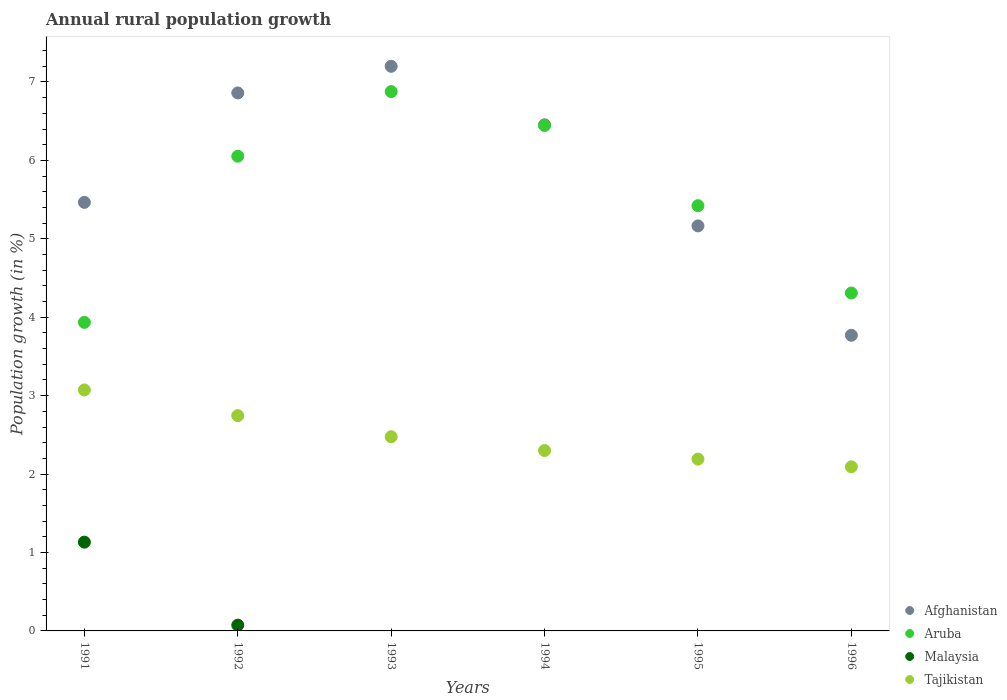How many different coloured dotlines are there?
Provide a succinct answer. 4. Is the number of dotlines equal to the number of legend labels?
Make the answer very short. No. What is the percentage of rural population growth in Malaysia in 1992?
Make the answer very short. 0.07. Across all years, what is the maximum percentage of rural population growth in Malaysia?
Make the answer very short. 1.13. Across all years, what is the minimum percentage of rural population growth in Afghanistan?
Make the answer very short. 3.77. What is the total percentage of rural population growth in Tajikistan in the graph?
Keep it short and to the point. 14.88. What is the difference between the percentage of rural population growth in Aruba in 1992 and that in 1996?
Make the answer very short. 1.74. What is the difference between the percentage of rural population growth in Aruba in 1991 and the percentage of rural population growth in Afghanistan in 1995?
Give a very brief answer. -1.23. What is the average percentage of rural population growth in Tajikistan per year?
Your answer should be compact. 2.48. In the year 1991, what is the difference between the percentage of rural population growth in Aruba and percentage of rural population growth in Tajikistan?
Your answer should be very brief. 0.86. In how many years, is the percentage of rural population growth in Aruba greater than 6 %?
Provide a short and direct response. 3. What is the ratio of the percentage of rural population growth in Tajikistan in 1991 to that in 1993?
Offer a terse response. 1.24. Is the difference between the percentage of rural population growth in Aruba in 1991 and 1994 greater than the difference between the percentage of rural population growth in Tajikistan in 1991 and 1994?
Make the answer very short. No. What is the difference between the highest and the second highest percentage of rural population growth in Aruba?
Keep it short and to the point. 0.43. What is the difference between the highest and the lowest percentage of rural population growth in Aruba?
Keep it short and to the point. 2.94. Is the sum of the percentage of rural population growth in Afghanistan in 1991 and 1992 greater than the maximum percentage of rural population growth in Aruba across all years?
Keep it short and to the point. Yes. Is it the case that in every year, the sum of the percentage of rural population growth in Malaysia and percentage of rural population growth in Aruba  is greater than the sum of percentage of rural population growth in Tajikistan and percentage of rural population growth in Afghanistan?
Offer a very short reply. No. Is it the case that in every year, the sum of the percentage of rural population growth in Afghanistan and percentage of rural population growth in Tajikistan  is greater than the percentage of rural population growth in Malaysia?
Offer a terse response. Yes. Does the percentage of rural population growth in Afghanistan monotonically increase over the years?
Your answer should be very brief. No. Is the percentage of rural population growth in Tajikistan strictly greater than the percentage of rural population growth in Aruba over the years?
Give a very brief answer. No. How many dotlines are there?
Your answer should be very brief. 4. How many years are there in the graph?
Give a very brief answer. 6. What is the difference between two consecutive major ticks on the Y-axis?
Your answer should be very brief. 1. Does the graph contain grids?
Give a very brief answer. No. Where does the legend appear in the graph?
Make the answer very short. Bottom right. How are the legend labels stacked?
Offer a very short reply. Vertical. What is the title of the graph?
Keep it short and to the point. Annual rural population growth. Does "Argentina" appear as one of the legend labels in the graph?
Give a very brief answer. No. What is the label or title of the Y-axis?
Offer a very short reply. Population growth (in %). What is the Population growth (in %) in Afghanistan in 1991?
Your answer should be compact. 5.46. What is the Population growth (in %) of Aruba in 1991?
Provide a short and direct response. 3.93. What is the Population growth (in %) of Malaysia in 1991?
Offer a very short reply. 1.13. What is the Population growth (in %) of Tajikistan in 1991?
Your response must be concise. 3.07. What is the Population growth (in %) of Afghanistan in 1992?
Your answer should be very brief. 6.86. What is the Population growth (in %) of Aruba in 1992?
Your answer should be very brief. 6.05. What is the Population growth (in %) in Malaysia in 1992?
Offer a very short reply. 0.07. What is the Population growth (in %) in Tajikistan in 1992?
Provide a succinct answer. 2.75. What is the Population growth (in %) of Afghanistan in 1993?
Keep it short and to the point. 7.2. What is the Population growth (in %) of Aruba in 1993?
Offer a very short reply. 6.88. What is the Population growth (in %) of Tajikistan in 1993?
Give a very brief answer. 2.48. What is the Population growth (in %) in Afghanistan in 1994?
Ensure brevity in your answer.  6.45. What is the Population growth (in %) of Aruba in 1994?
Offer a terse response. 6.44. What is the Population growth (in %) in Malaysia in 1994?
Keep it short and to the point. 0. What is the Population growth (in %) of Tajikistan in 1994?
Give a very brief answer. 2.3. What is the Population growth (in %) of Afghanistan in 1995?
Give a very brief answer. 5.16. What is the Population growth (in %) of Aruba in 1995?
Provide a short and direct response. 5.42. What is the Population growth (in %) in Tajikistan in 1995?
Your answer should be compact. 2.19. What is the Population growth (in %) of Afghanistan in 1996?
Give a very brief answer. 3.77. What is the Population growth (in %) in Aruba in 1996?
Provide a succinct answer. 4.31. What is the Population growth (in %) of Malaysia in 1996?
Give a very brief answer. 0. What is the Population growth (in %) of Tajikistan in 1996?
Ensure brevity in your answer.  2.09. Across all years, what is the maximum Population growth (in %) in Afghanistan?
Your response must be concise. 7.2. Across all years, what is the maximum Population growth (in %) in Aruba?
Offer a very short reply. 6.88. Across all years, what is the maximum Population growth (in %) in Malaysia?
Offer a terse response. 1.13. Across all years, what is the maximum Population growth (in %) in Tajikistan?
Offer a terse response. 3.07. Across all years, what is the minimum Population growth (in %) in Afghanistan?
Make the answer very short. 3.77. Across all years, what is the minimum Population growth (in %) of Aruba?
Ensure brevity in your answer.  3.93. Across all years, what is the minimum Population growth (in %) of Malaysia?
Your answer should be compact. 0. Across all years, what is the minimum Population growth (in %) in Tajikistan?
Offer a very short reply. 2.09. What is the total Population growth (in %) of Afghanistan in the graph?
Your answer should be very brief. 34.91. What is the total Population growth (in %) of Aruba in the graph?
Provide a succinct answer. 33.04. What is the total Population growth (in %) in Malaysia in the graph?
Keep it short and to the point. 1.21. What is the total Population growth (in %) in Tajikistan in the graph?
Make the answer very short. 14.88. What is the difference between the Population growth (in %) in Afghanistan in 1991 and that in 1992?
Offer a terse response. -1.4. What is the difference between the Population growth (in %) of Aruba in 1991 and that in 1992?
Ensure brevity in your answer.  -2.12. What is the difference between the Population growth (in %) in Malaysia in 1991 and that in 1992?
Make the answer very short. 1.06. What is the difference between the Population growth (in %) in Tajikistan in 1991 and that in 1992?
Provide a short and direct response. 0.33. What is the difference between the Population growth (in %) of Afghanistan in 1991 and that in 1993?
Give a very brief answer. -1.73. What is the difference between the Population growth (in %) of Aruba in 1991 and that in 1993?
Your response must be concise. -2.94. What is the difference between the Population growth (in %) of Tajikistan in 1991 and that in 1993?
Make the answer very short. 0.6. What is the difference between the Population growth (in %) in Afghanistan in 1991 and that in 1994?
Make the answer very short. -0.99. What is the difference between the Population growth (in %) in Aruba in 1991 and that in 1994?
Keep it short and to the point. -2.51. What is the difference between the Population growth (in %) in Tajikistan in 1991 and that in 1994?
Offer a very short reply. 0.77. What is the difference between the Population growth (in %) in Afghanistan in 1991 and that in 1995?
Your answer should be compact. 0.3. What is the difference between the Population growth (in %) of Aruba in 1991 and that in 1995?
Provide a succinct answer. -1.49. What is the difference between the Population growth (in %) in Tajikistan in 1991 and that in 1995?
Your answer should be very brief. 0.88. What is the difference between the Population growth (in %) of Afghanistan in 1991 and that in 1996?
Offer a very short reply. 1.69. What is the difference between the Population growth (in %) of Aruba in 1991 and that in 1996?
Give a very brief answer. -0.37. What is the difference between the Population growth (in %) in Tajikistan in 1991 and that in 1996?
Provide a short and direct response. 0.98. What is the difference between the Population growth (in %) of Afghanistan in 1992 and that in 1993?
Ensure brevity in your answer.  -0.34. What is the difference between the Population growth (in %) of Aruba in 1992 and that in 1993?
Ensure brevity in your answer.  -0.82. What is the difference between the Population growth (in %) of Tajikistan in 1992 and that in 1993?
Ensure brevity in your answer.  0.27. What is the difference between the Population growth (in %) of Afghanistan in 1992 and that in 1994?
Provide a short and direct response. 0.41. What is the difference between the Population growth (in %) of Aruba in 1992 and that in 1994?
Your answer should be compact. -0.39. What is the difference between the Population growth (in %) in Tajikistan in 1992 and that in 1994?
Your answer should be very brief. 0.45. What is the difference between the Population growth (in %) of Afghanistan in 1992 and that in 1995?
Make the answer very short. 1.7. What is the difference between the Population growth (in %) in Aruba in 1992 and that in 1995?
Keep it short and to the point. 0.63. What is the difference between the Population growth (in %) in Tajikistan in 1992 and that in 1995?
Your answer should be compact. 0.55. What is the difference between the Population growth (in %) in Afghanistan in 1992 and that in 1996?
Your answer should be compact. 3.09. What is the difference between the Population growth (in %) in Aruba in 1992 and that in 1996?
Make the answer very short. 1.74. What is the difference between the Population growth (in %) in Tajikistan in 1992 and that in 1996?
Offer a terse response. 0.65. What is the difference between the Population growth (in %) of Afghanistan in 1993 and that in 1994?
Your response must be concise. 0.75. What is the difference between the Population growth (in %) in Aruba in 1993 and that in 1994?
Give a very brief answer. 0.43. What is the difference between the Population growth (in %) in Tajikistan in 1993 and that in 1994?
Offer a terse response. 0.18. What is the difference between the Population growth (in %) of Afghanistan in 1993 and that in 1995?
Your response must be concise. 2.04. What is the difference between the Population growth (in %) in Aruba in 1993 and that in 1995?
Offer a terse response. 1.46. What is the difference between the Population growth (in %) in Tajikistan in 1993 and that in 1995?
Ensure brevity in your answer.  0.29. What is the difference between the Population growth (in %) of Afghanistan in 1993 and that in 1996?
Your answer should be compact. 3.43. What is the difference between the Population growth (in %) in Aruba in 1993 and that in 1996?
Your answer should be very brief. 2.57. What is the difference between the Population growth (in %) of Tajikistan in 1993 and that in 1996?
Offer a terse response. 0.38. What is the difference between the Population growth (in %) in Afghanistan in 1994 and that in 1995?
Keep it short and to the point. 1.29. What is the difference between the Population growth (in %) of Aruba in 1994 and that in 1995?
Make the answer very short. 1.02. What is the difference between the Population growth (in %) of Tajikistan in 1994 and that in 1995?
Provide a short and direct response. 0.11. What is the difference between the Population growth (in %) of Afghanistan in 1994 and that in 1996?
Ensure brevity in your answer.  2.68. What is the difference between the Population growth (in %) in Aruba in 1994 and that in 1996?
Make the answer very short. 2.14. What is the difference between the Population growth (in %) in Tajikistan in 1994 and that in 1996?
Offer a very short reply. 0.21. What is the difference between the Population growth (in %) in Afghanistan in 1995 and that in 1996?
Offer a very short reply. 1.39. What is the difference between the Population growth (in %) of Aruba in 1995 and that in 1996?
Your answer should be compact. 1.11. What is the difference between the Population growth (in %) of Tajikistan in 1995 and that in 1996?
Make the answer very short. 0.1. What is the difference between the Population growth (in %) in Afghanistan in 1991 and the Population growth (in %) in Aruba in 1992?
Offer a very short reply. -0.59. What is the difference between the Population growth (in %) in Afghanistan in 1991 and the Population growth (in %) in Malaysia in 1992?
Make the answer very short. 5.39. What is the difference between the Population growth (in %) in Afghanistan in 1991 and the Population growth (in %) in Tajikistan in 1992?
Provide a succinct answer. 2.72. What is the difference between the Population growth (in %) of Aruba in 1991 and the Population growth (in %) of Malaysia in 1992?
Offer a very short reply. 3.86. What is the difference between the Population growth (in %) in Aruba in 1991 and the Population growth (in %) in Tajikistan in 1992?
Your response must be concise. 1.19. What is the difference between the Population growth (in %) of Malaysia in 1991 and the Population growth (in %) of Tajikistan in 1992?
Your answer should be very brief. -1.61. What is the difference between the Population growth (in %) of Afghanistan in 1991 and the Population growth (in %) of Aruba in 1993?
Your answer should be compact. -1.41. What is the difference between the Population growth (in %) of Afghanistan in 1991 and the Population growth (in %) of Tajikistan in 1993?
Your response must be concise. 2.99. What is the difference between the Population growth (in %) of Aruba in 1991 and the Population growth (in %) of Tajikistan in 1993?
Offer a very short reply. 1.46. What is the difference between the Population growth (in %) of Malaysia in 1991 and the Population growth (in %) of Tajikistan in 1993?
Provide a succinct answer. -1.34. What is the difference between the Population growth (in %) of Afghanistan in 1991 and the Population growth (in %) of Aruba in 1994?
Your response must be concise. -0.98. What is the difference between the Population growth (in %) of Afghanistan in 1991 and the Population growth (in %) of Tajikistan in 1994?
Keep it short and to the point. 3.16. What is the difference between the Population growth (in %) of Aruba in 1991 and the Population growth (in %) of Tajikistan in 1994?
Make the answer very short. 1.63. What is the difference between the Population growth (in %) in Malaysia in 1991 and the Population growth (in %) in Tajikistan in 1994?
Offer a terse response. -1.17. What is the difference between the Population growth (in %) of Afghanistan in 1991 and the Population growth (in %) of Aruba in 1995?
Offer a terse response. 0.04. What is the difference between the Population growth (in %) in Afghanistan in 1991 and the Population growth (in %) in Tajikistan in 1995?
Keep it short and to the point. 3.27. What is the difference between the Population growth (in %) in Aruba in 1991 and the Population growth (in %) in Tajikistan in 1995?
Make the answer very short. 1.74. What is the difference between the Population growth (in %) of Malaysia in 1991 and the Population growth (in %) of Tajikistan in 1995?
Provide a succinct answer. -1.06. What is the difference between the Population growth (in %) of Afghanistan in 1991 and the Population growth (in %) of Aruba in 1996?
Ensure brevity in your answer.  1.16. What is the difference between the Population growth (in %) of Afghanistan in 1991 and the Population growth (in %) of Tajikistan in 1996?
Make the answer very short. 3.37. What is the difference between the Population growth (in %) in Aruba in 1991 and the Population growth (in %) in Tajikistan in 1996?
Offer a terse response. 1.84. What is the difference between the Population growth (in %) of Malaysia in 1991 and the Population growth (in %) of Tajikistan in 1996?
Make the answer very short. -0.96. What is the difference between the Population growth (in %) in Afghanistan in 1992 and the Population growth (in %) in Aruba in 1993?
Your answer should be compact. -0.02. What is the difference between the Population growth (in %) of Afghanistan in 1992 and the Population growth (in %) of Tajikistan in 1993?
Ensure brevity in your answer.  4.38. What is the difference between the Population growth (in %) in Aruba in 1992 and the Population growth (in %) in Tajikistan in 1993?
Your answer should be compact. 3.58. What is the difference between the Population growth (in %) in Malaysia in 1992 and the Population growth (in %) in Tajikistan in 1993?
Your answer should be very brief. -2.4. What is the difference between the Population growth (in %) in Afghanistan in 1992 and the Population growth (in %) in Aruba in 1994?
Give a very brief answer. 0.42. What is the difference between the Population growth (in %) of Afghanistan in 1992 and the Population growth (in %) of Tajikistan in 1994?
Your answer should be compact. 4.56. What is the difference between the Population growth (in %) in Aruba in 1992 and the Population growth (in %) in Tajikistan in 1994?
Your answer should be compact. 3.75. What is the difference between the Population growth (in %) of Malaysia in 1992 and the Population growth (in %) of Tajikistan in 1994?
Give a very brief answer. -2.23. What is the difference between the Population growth (in %) in Afghanistan in 1992 and the Population growth (in %) in Aruba in 1995?
Ensure brevity in your answer.  1.44. What is the difference between the Population growth (in %) in Afghanistan in 1992 and the Population growth (in %) in Tajikistan in 1995?
Keep it short and to the point. 4.67. What is the difference between the Population growth (in %) of Aruba in 1992 and the Population growth (in %) of Tajikistan in 1995?
Your answer should be very brief. 3.86. What is the difference between the Population growth (in %) in Malaysia in 1992 and the Population growth (in %) in Tajikistan in 1995?
Your answer should be very brief. -2.12. What is the difference between the Population growth (in %) of Afghanistan in 1992 and the Population growth (in %) of Aruba in 1996?
Your response must be concise. 2.55. What is the difference between the Population growth (in %) in Afghanistan in 1992 and the Population growth (in %) in Tajikistan in 1996?
Make the answer very short. 4.77. What is the difference between the Population growth (in %) in Aruba in 1992 and the Population growth (in %) in Tajikistan in 1996?
Your answer should be compact. 3.96. What is the difference between the Population growth (in %) of Malaysia in 1992 and the Population growth (in %) of Tajikistan in 1996?
Make the answer very short. -2.02. What is the difference between the Population growth (in %) of Afghanistan in 1993 and the Population growth (in %) of Aruba in 1994?
Provide a succinct answer. 0.75. What is the difference between the Population growth (in %) of Afghanistan in 1993 and the Population growth (in %) of Tajikistan in 1994?
Your response must be concise. 4.9. What is the difference between the Population growth (in %) of Aruba in 1993 and the Population growth (in %) of Tajikistan in 1994?
Make the answer very short. 4.58. What is the difference between the Population growth (in %) in Afghanistan in 1993 and the Population growth (in %) in Aruba in 1995?
Your response must be concise. 1.78. What is the difference between the Population growth (in %) of Afghanistan in 1993 and the Population growth (in %) of Tajikistan in 1995?
Your response must be concise. 5.01. What is the difference between the Population growth (in %) in Aruba in 1993 and the Population growth (in %) in Tajikistan in 1995?
Ensure brevity in your answer.  4.69. What is the difference between the Population growth (in %) of Afghanistan in 1993 and the Population growth (in %) of Aruba in 1996?
Offer a terse response. 2.89. What is the difference between the Population growth (in %) in Afghanistan in 1993 and the Population growth (in %) in Tajikistan in 1996?
Your answer should be very brief. 5.11. What is the difference between the Population growth (in %) of Aruba in 1993 and the Population growth (in %) of Tajikistan in 1996?
Give a very brief answer. 4.78. What is the difference between the Population growth (in %) of Afghanistan in 1994 and the Population growth (in %) of Aruba in 1995?
Give a very brief answer. 1.03. What is the difference between the Population growth (in %) in Afghanistan in 1994 and the Population growth (in %) in Tajikistan in 1995?
Your answer should be compact. 4.26. What is the difference between the Population growth (in %) in Aruba in 1994 and the Population growth (in %) in Tajikistan in 1995?
Provide a short and direct response. 4.25. What is the difference between the Population growth (in %) of Afghanistan in 1994 and the Population growth (in %) of Aruba in 1996?
Your answer should be compact. 2.14. What is the difference between the Population growth (in %) of Afghanistan in 1994 and the Population growth (in %) of Tajikistan in 1996?
Make the answer very short. 4.36. What is the difference between the Population growth (in %) in Aruba in 1994 and the Population growth (in %) in Tajikistan in 1996?
Your answer should be compact. 4.35. What is the difference between the Population growth (in %) of Afghanistan in 1995 and the Population growth (in %) of Aruba in 1996?
Your answer should be very brief. 0.86. What is the difference between the Population growth (in %) in Afghanistan in 1995 and the Population growth (in %) in Tajikistan in 1996?
Provide a short and direct response. 3.07. What is the difference between the Population growth (in %) in Aruba in 1995 and the Population growth (in %) in Tajikistan in 1996?
Provide a short and direct response. 3.33. What is the average Population growth (in %) of Afghanistan per year?
Give a very brief answer. 5.82. What is the average Population growth (in %) of Aruba per year?
Make the answer very short. 5.51. What is the average Population growth (in %) in Malaysia per year?
Provide a succinct answer. 0.2. What is the average Population growth (in %) of Tajikistan per year?
Provide a short and direct response. 2.48. In the year 1991, what is the difference between the Population growth (in %) of Afghanistan and Population growth (in %) of Aruba?
Your answer should be compact. 1.53. In the year 1991, what is the difference between the Population growth (in %) in Afghanistan and Population growth (in %) in Malaysia?
Keep it short and to the point. 4.33. In the year 1991, what is the difference between the Population growth (in %) of Afghanistan and Population growth (in %) of Tajikistan?
Keep it short and to the point. 2.39. In the year 1991, what is the difference between the Population growth (in %) in Aruba and Population growth (in %) in Malaysia?
Your answer should be compact. 2.8. In the year 1991, what is the difference between the Population growth (in %) of Aruba and Population growth (in %) of Tajikistan?
Your response must be concise. 0.86. In the year 1991, what is the difference between the Population growth (in %) in Malaysia and Population growth (in %) in Tajikistan?
Your answer should be compact. -1.94. In the year 1992, what is the difference between the Population growth (in %) of Afghanistan and Population growth (in %) of Aruba?
Your answer should be compact. 0.81. In the year 1992, what is the difference between the Population growth (in %) in Afghanistan and Population growth (in %) in Malaysia?
Offer a very short reply. 6.79. In the year 1992, what is the difference between the Population growth (in %) of Afghanistan and Population growth (in %) of Tajikistan?
Your response must be concise. 4.11. In the year 1992, what is the difference between the Population growth (in %) in Aruba and Population growth (in %) in Malaysia?
Provide a short and direct response. 5.98. In the year 1992, what is the difference between the Population growth (in %) of Aruba and Population growth (in %) of Tajikistan?
Ensure brevity in your answer.  3.31. In the year 1992, what is the difference between the Population growth (in %) of Malaysia and Population growth (in %) of Tajikistan?
Give a very brief answer. -2.67. In the year 1993, what is the difference between the Population growth (in %) of Afghanistan and Population growth (in %) of Aruba?
Make the answer very short. 0.32. In the year 1993, what is the difference between the Population growth (in %) of Afghanistan and Population growth (in %) of Tajikistan?
Ensure brevity in your answer.  4.72. In the year 1993, what is the difference between the Population growth (in %) in Aruba and Population growth (in %) in Tajikistan?
Your answer should be compact. 4.4. In the year 1994, what is the difference between the Population growth (in %) in Afghanistan and Population growth (in %) in Aruba?
Ensure brevity in your answer.  0.01. In the year 1994, what is the difference between the Population growth (in %) in Afghanistan and Population growth (in %) in Tajikistan?
Your response must be concise. 4.15. In the year 1994, what is the difference between the Population growth (in %) in Aruba and Population growth (in %) in Tajikistan?
Keep it short and to the point. 4.14. In the year 1995, what is the difference between the Population growth (in %) in Afghanistan and Population growth (in %) in Aruba?
Offer a terse response. -0.26. In the year 1995, what is the difference between the Population growth (in %) in Afghanistan and Population growth (in %) in Tajikistan?
Provide a succinct answer. 2.97. In the year 1995, what is the difference between the Population growth (in %) in Aruba and Population growth (in %) in Tajikistan?
Your answer should be very brief. 3.23. In the year 1996, what is the difference between the Population growth (in %) in Afghanistan and Population growth (in %) in Aruba?
Keep it short and to the point. -0.54. In the year 1996, what is the difference between the Population growth (in %) in Afghanistan and Population growth (in %) in Tajikistan?
Your answer should be very brief. 1.68. In the year 1996, what is the difference between the Population growth (in %) in Aruba and Population growth (in %) in Tajikistan?
Provide a short and direct response. 2.22. What is the ratio of the Population growth (in %) of Afghanistan in 1991 to that in 1992?
Your answer should be very brief. 0.8. What is the ratio of the Population growth (in %) of Aruba in 1991 to that in 1992?
Offer a very short reply. 0.65. What is the ratio of the Population growth (in %) in Malaysia in 1991 to that in 1992?
Offer a very short reply. 15.34. What is the ratio of the Population growth (in %) of Tajikistan in 1991 to that in 1992?
Ensure brevity in your answer.  1.12. What is the ratio of the Population growth (in %) in Afghanistan in 1991 to that in 1993?
Ensure brevity in your answer.  0.76. What is the ratio of the Population growth (in %) in Aruba in 1991 to that in 1993?
Provide a short and direct response. 0.57. What is the ratio of the Population growth (in %) of Tajikistan in 1991 to that in 1993?
Keep it short and to the point. 1.24. What is the ratio of the Population growth (in %) in Afghanistan in 1991 to that in 1994?
Offer a terse response. 0.85. What is the ratio of the Population growth (in %) of Aruba in 1991 to that in 1994?
Make the answer very short. 0.61. What is the ratio of the Population growth (in %) in Tajikistan in 1991 to that in 1994?
Your response must be concise. 1.34. What is the ratio of the Population growth (in %) of Afghanistan in 1991 to that in 1995?
Your answer should be compact. 1.06. What is the ratio of the Population growth (in %) of Aruba in 1991 to that in 1995?
Keep it short and to the point. 0.73. What is the ratio of the Population growth (in %) of Tajikistan in 1991 to that in 1995?
Keep it short and to the point. 1.4. What is the ratio of the Population growth (in %) of Afghanistan in 1991 to that in 1996?
Your response must be concise. 1.45. What is the ratio of the Population growth (in %) in Aruba in 1991 to that in 1996?
Provide a short and direct response. 0.91. What is the ratio of the Population growth (in %) in Tajikistan in 1991 to that in 1996?
Offer a terse response. 1.47. What is the ratio of the Population growth (in %) of Afghanistan in 1992 to that in 1993?
Offer a terse response. 0.95. What is the ratio of the Population growth (in %) in Aruba in 1992 to that in 1993?
Provide a short and direct response. 0.88. What is the ratio of the Population growth (in %) of Tajikistan in 1992 to that in 1993?
Provide a short and direct response. 1.11. What is the ratio of the Population growth (in %) in Afghanistan in 1992 to that in 1994?
Ensure brevity in your answer.  1.06. What is the ratio of the Population growth (in %) of Aruba in 1992 to that in 1994?
Your answer should be very brief. 0.94. What is the ratio of the Population growth (in %) in Tajikistan in 1992 to that in 1994?
Provide a succinct answer. 1.19. What is the ratio of the Population growth (in %) in Afghanistan in 1992 to that in 1995?
Provide a short and direct response. 1.33. What is the ratio of the Population growth (in %) of Aruba in 1992 to that in 1995?
Ensure brevity in your answer.  1.12. What is the ratio of the Population growth (in %) of Tajikistan in 1992 to that in 1995?
Your answer should be very brief. 1.25. What is the ratio of the Population growth (in %) of Afghanistan in 1992 to that in 1996?
Offer a very short reply. 1.82. What is the ratio of the Population growth (in %) of Aruba in 1992 to that in 1996?
Provide a succinct answer. 1.4. What is the ratio of the Population growth (in %) of Tajikistan in 1992 to that in 1996?
Provide a succinct answer. 1.31. What is the ratio of the Population growth (in %) in Afghanistan in 1993 to that in 1994?
Offer a terse response. 1.12. What is the ratio of the Population growth (in %) in Aruba in 1993 to that in 1994?
Keep it short and to the point. 1.07. What is the ratio of the Population growth (in %) of Tajikistan in 1993 to that in 1994?
Your response must be concise. 1.08. What is the ratio of the Population growth (in %) in Afghanistan in 1993 to that in 1995?
Your answer should be very brief. 1.39. What is the ratio of the Population growth (in %) of Aruba in 1993 to that in 1995?
Provide a short and direct response. 1.27. What is the ratio of the Population growth (in %) of Tajikistan in 1993 to that in 1995?
Your answer should be very brief. 1.13. What is the ratio of the Population growth (in %) of Afghanistan in 1993 to that in 1996?
Give a very brief answer. 1.91. What is the ratio of the Population growth (in %) in Aruba in 1993 to that in 1996?
Ensure brevity in your answer.  1.6. What is the ratio of the Population growth (in %) of Tajikistan in 1993 to that in 1996?
Make the answer very short. 1.18. What is the ratio of the Population growth (in %) of Afghanistan in 1994 to that in 1995?
Give a very brief answer. 1.25. What is the ratio of the Population growth (in %) in Aruba in 1994 to that in 1995?
Your response must be concise. 1.19. What is the ratio of the Population growth (in %) of Tajikistan in 1994 to that in 1995?
Offer a terse response. 1.05. What is the ratio of the Population growth (in %) of Afghanistan in 1994 to that in 1996?
Your response must be concise. 1.71. What is the ratio of the Population growth (in %) of Aruba in 1994 to that in 1996?
Your answer should be compact. 1.5. What is the ratio of the Population growth (in %) of Tajikistan in 1994 to that in 1996?
Ensure brevity in your answer.  1.1. What is the ratio of the Population growth (in %) of Afghanistan in 1995 to that in 1996?
Give a very brief answer. 1.37. What is the ratio of the Population growth (in %) in Aruba in 1995 to that in 1996?
Offer a terse response. 1.26. What is the ratio of the Population growth (in %) of Tajikistan in 1995 to that in 1996?
Provide a short and direct response. 1.05. What is the difference between the highest and the second highest Population growth (in %) in Afghanistan?
Offer a terse response. 0.34. What is the difference between the highest and the second highest Population growth (in %) of Aruba?
Offer a terse response. 0.43. What is the difference between the highest and the second highest Population growth (in %) in Tajikistan?
Give a very brief answer. 0.33. What is the difference between the highest and the lowest Population growth (in %) of Afghanistan?
Your response must be concise. 3.43. What is the difference between the highest and the lowest Population growth (in %) in Aruba?
Make the answer very short. 2.94. What is the difference between the highest and the lowest Population growth (in %) of Malaysia?
Your answer should be very brief. 1.13. 